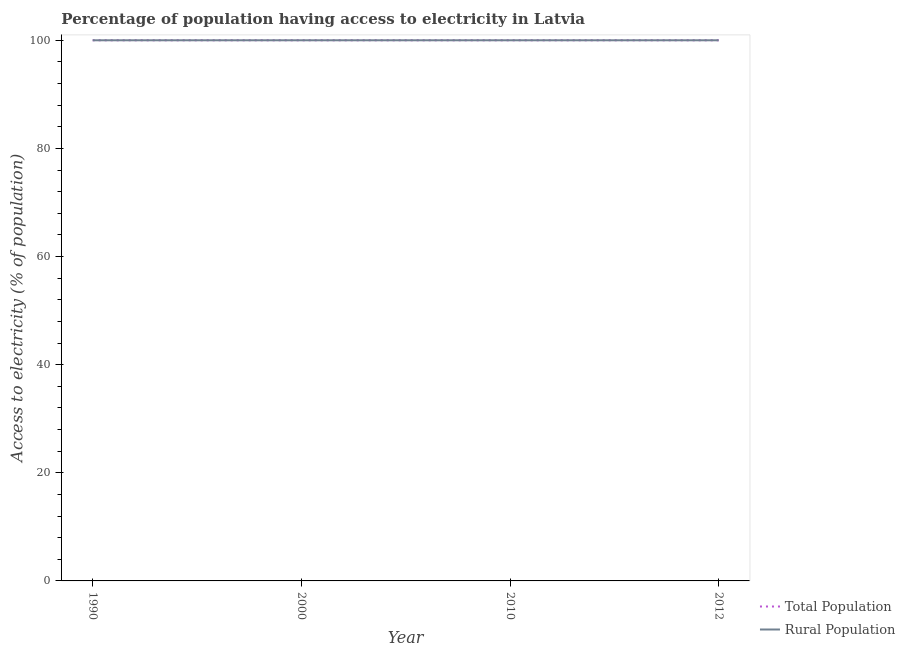Does the line corresponding to percentage of population having access to electricity intersect with the line corresponding to percentage of rural population having access to electricity?
Provide a short and direct response. Yes. Is the number of lines equal to the number of legend labels?
Give a very brief answer. Yes. What is the percentage of population having access to electricity in 2000?
Make the answer very short. 100. Across all years, what is the maximum percentage of rural population having access to electricity?
Your answer should be very brief. 100. Across all years, what is the minimum percentage of population having access to electricity?
Provide a short and direct response. 100. In which year was the percentage of population having access to electricity maximum?
Keep it short and to the point. 1990. In which year was the percentage of rural population having access to electricity minimum?
Give a very brief answer. 1990. What is the total percentage of population having access to electricity in the graph?
Ensure brevity in your answer.  400. What is the difference between the percentage of population having access to electricity in 2010 and the percentage of rural population having access to electricity in 2012?
Give a very brief answer. 0. In the year 2000, what is the difference between the percentage of rural population having access to electricity and percentage of population having access to electricity?
Offer a terse response. 0. In how many years, is the percentage of rural population having access to electricity greater than 44 %?
Keep it short and to the point. 4. What is the ratio of the percentage of population having access to electricity in 1990 to that in 2010?
Give a very brief answer. 1. Is the difference between the percentage of rural population having access to electricity in 2010 and 2012 greater than the difference between the percentage of population having access to electricity in 2010 and 2012?
Your answer should be compact. No. What is the difference between the highest and the second highest percentage of population having access to electricity?
Provide a short and direct response. 0. In how many years, is the percentage of rural population having access to electricity greater than the average percentage of rural population having access to electricity taken over all years?
Provide a short and direct response. 0. Is the percentage of rural population having access to electricity strictly greater than the percentage of population having access to electricity over the years?
Offer a terse response. No. How many lines are there?
Your response must be concise. 2. How many years are there in the graph?
Keep it short and to the point. 4. What is the difference between two consecutive major ticks on the Y-axis?
Provide a succinct answer. 20. Where does the legend appear in the graph?
Give a very brief answer. Bottom right. How many legend labels are there?
Provide a short and direct response. 2. How are the legend labels stacked?
Keep it short and to the point. Vertical. What is the title of the graph?
Give a very brief answer. Percentage of population having access to electricity in Latvia. Does "Commercial bank branches" appear as one of the legend labels in the graph?
Provide a short and direct response. No. What is the label or title of the Y-axis?
Make the answer very short. Access to electricity (% of population). What is the Access to electricity (% of population) in Total Population in 1990?
Keep it short and to the point. 100. What is the Access to electricity (% of population) of Rural Population in 2000?
Keep it short and to the point. 100. What is the Access to electricity (% of population) in Rural Population in 2010?
Make the answer very short. 100. Across all years, what is the maximum Access to electricity (% of population) of Total Population?
Make the answer very short. 100. What is the difference between the Access to electricity (% of population) in Total Population in 1990 and that in 2000?
Make the answer very short. 0. What is the difference between the Access to electricity (% of population) of Total Population in 1990 and that in 2010?
Make the answer very short. 0. What is the difference between the Access to electricity (% of population) of Rural Population in 1990 and that in 2010?
Provide a short and direct response. 0. What is the difference between the Access to electricity (% of population) of Total Population in 2000 and that in 2012?
Keep it short and to the point. 0. What is the difference between the Access to electricity (% of population) of Total Population in 1990 and the Access to electricity (% of population) of Rural Population in 2000?
Provide a short and direct response. 0. What is the difference between the Access to electricity (% of population) of Total Population in 1990 and the Access to electricity (% of population) of Rural Population in 2012?
Offer a terse response. 0. What is the difference between the Access to electricity (% of population) in Total Population in 2000 and the Access to electricity (% of population) in Rural Population in 2010?
Make the answer very short. 0. What is the difference between the Access to electricity (% of population) in Total Population in 2000 and the Access to electricity (% of population) in Rural Population in 2012?
Offer a very short reply. 0. In the year 2012, what is the difference between the Access to electricity (% of population) in Total Population and Access to electricity (% of population) in Rural Population?
Give a very brief answer. 0. What is the ratio of the Access to electricity (% of population) of Rural Population in 2000 to that in 2010?
Your answer should be very brief. 1. What is the ratio of the Access to electricity (% of population) in Rural Population in 2000 to that in 2012?
Offer a terse response. 1. What is the ratio of the Access to electricity (% of population) in Total Population in 2010 to that in 2012?
Provide a short and direct response. 1. What is the difference between the highest and the second highest Access to electricity (% of population) of Total Population?
Give a very brief answer. 0. What is the difference between the highest and the lowest Access to electricity (% of population) of Rural Population?
Give a very brief answer. 0. 